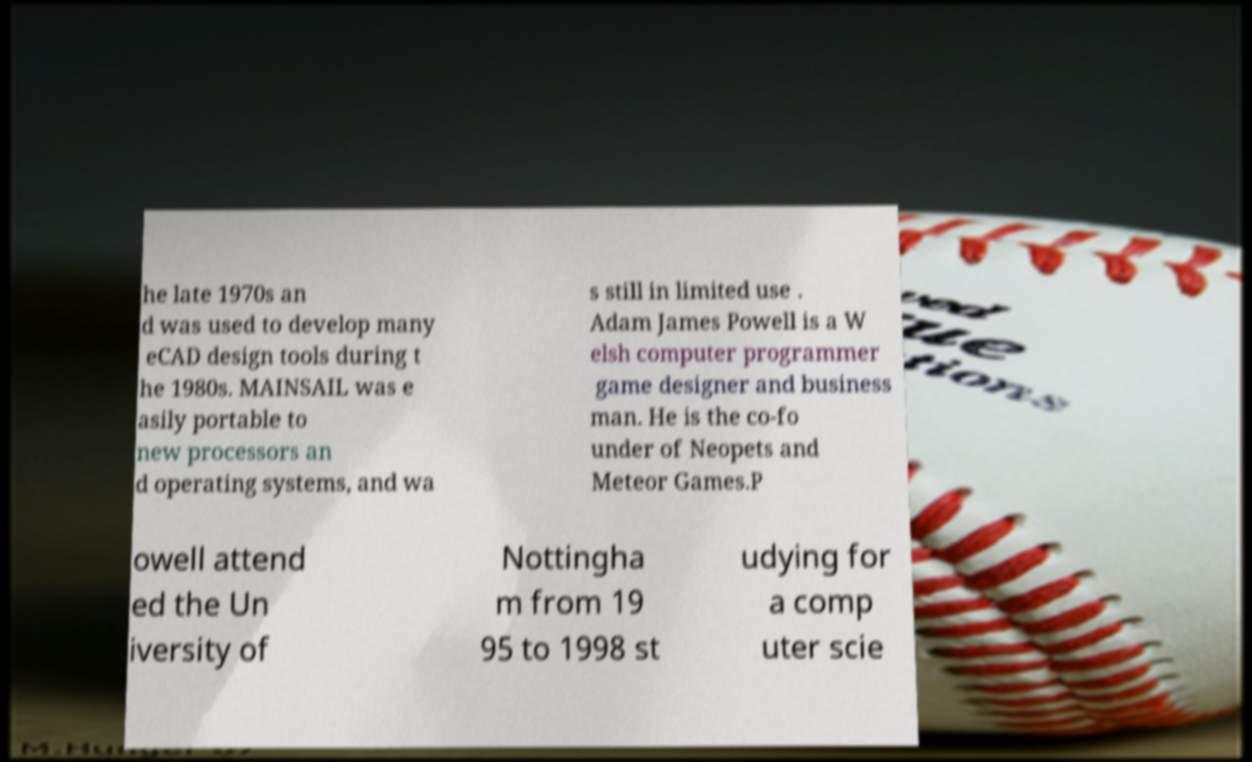What messages or text are displayed in this image? I need them in a readable, typed format. he late 1970s an d was used to develop many eCAD design tools during t he 1980s. MAINSAIL was e asily portable to new processors an d operating systems, and wa s still in limited use . Adam James Powell is a W elsh computer programmer game designer and business man. He is the co-fo under of Neopets and Meteor Games.P owell attend ed the Un iversity of Nottingha m from 19 95 to 1998 st udying for a comp uter scie 